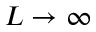Convert formula to latex. <formula><loc_0><loc_0><loc_500><loc_500>L \to \infty</formula> 